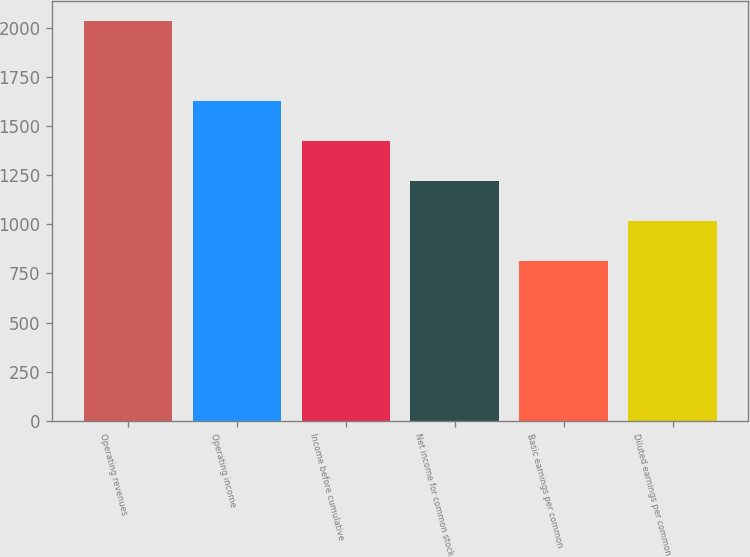<chart> <loc_0><loc_0><loc_500><loc_500><bar_chart><fcel>Operating revenues<fcel>Operating income<fcel>Income before cumulative<fcel>Net income for common stock<fcel>Basic earnings per common<fcel>Diluted earnings per common<nl><fcel>2036.4<fcel>1629.24<fcel>1425.67<fcel>1222.1<fcel>814.96<fcel>1018.53<nl></chart> 